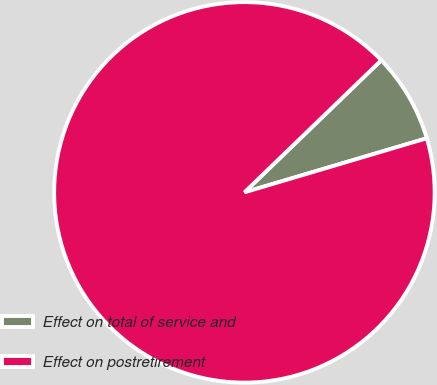Convert chart. <chart><loc_0><loc_0><loc_500><loc_500><pie_chart><fcel>Effect on total of service and<fcel>Effect on postretirement<nl><fcel>7.63%<fcel>92.37%<nl></chart> 